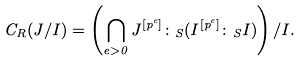Convert formula to latex. <formula><loc_0><loc_0><loc_500><loc_500>C _ { R } ( J / I ) = \left ( \bigcap _ { e > 0 } J ^ { [ p ^ { e } ] } \colon _ { S } ( I ^ { [ p ^ { e } ] } \colon _ { S } I ) \right ) / I .</formula> 